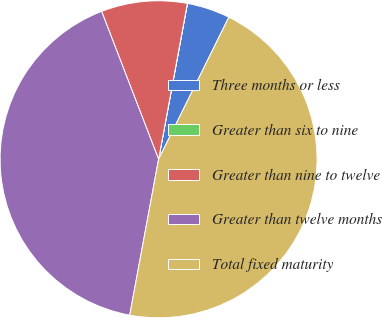<chart> <loc_0><loc_0><loc_500><loc_500><pie_chart><fcel>Three months or less<fcel>Greater than six to nine<fcel>Greater than nine to twelve<fcel>Greater than twelve months<fcel>Total fixed maturity<nl><fcel>4.39%<fcel>0.01%<fcel>8.76%<fcel>41.23%<fcel>45.61%<nl></chart> 